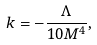Convert formula to latex. <formula><loc_0><loc_0><loc_500><loc_500>k = - \frac { \Lambda } { 1 0 M ^ { 4 } } ,</formula> 